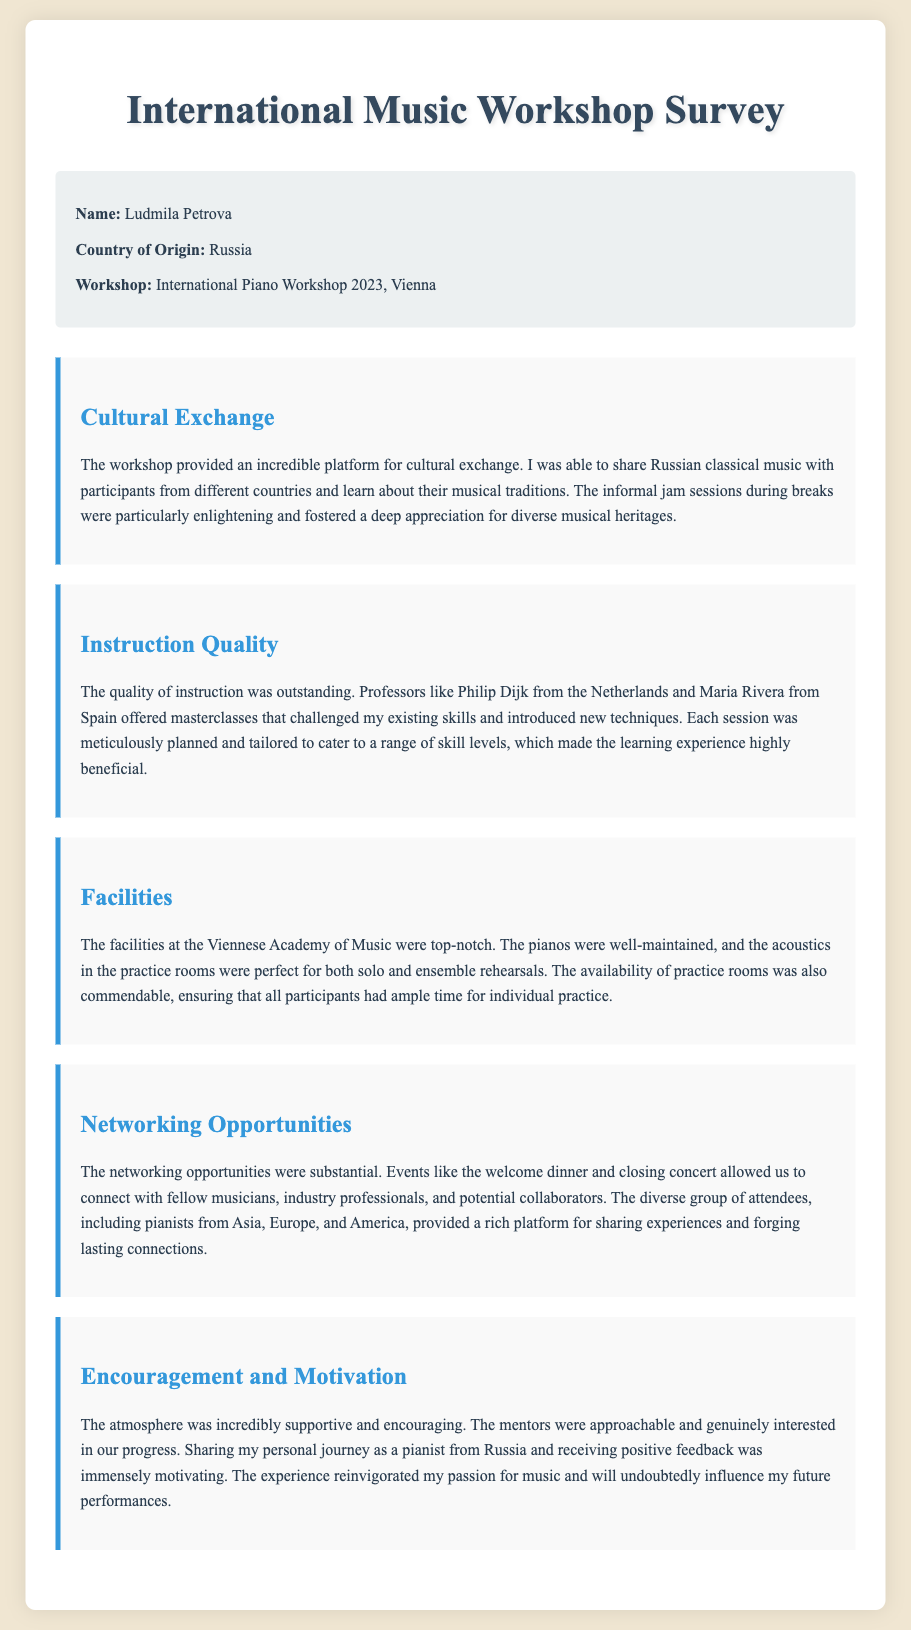What is the name of the participant? The participant's name is provided in the document as part of the participant information section.
Answer: Ludmila Petrova What country does the participant come from? The country of origin for the participant is clearly stated in the participant information section of the document.
Answer: Russia Which workshop did the participant attend? The document specifies the exact workshop that the participant attended in the workshop section.
Answer: International Piano Workshop 2023, Vienna Who were the instructors mentioned? The document lists names of specific professors who conducted masterclasses, indicating their contributions to the workshop.
Answer: Philip Dijk, Maria Rivera What aspect of the workshop emphasized cultural exchange? The participant's feedback specifically highlights the cultural exchange aspect in the feedback section.
Answer: Sharing Russian classical music What kind of facilities were available at the venue? The document describes the quality and maintenance of the facilities which were important for the learning experience.
Answer: Top-notch pianos and perfect acoustics How did the participant feel about the encouragement received? The feedback elaborates on the supportive atmosphere and the participant's feelings regarding the mentorship they received.
Answer: Immensely motivating What opportunities did the workshop provide for networking? The document mentions specific events that fostered networking, highlighting the interaction with various individuals in music.
Answer: Welcome dinner and closing concert 